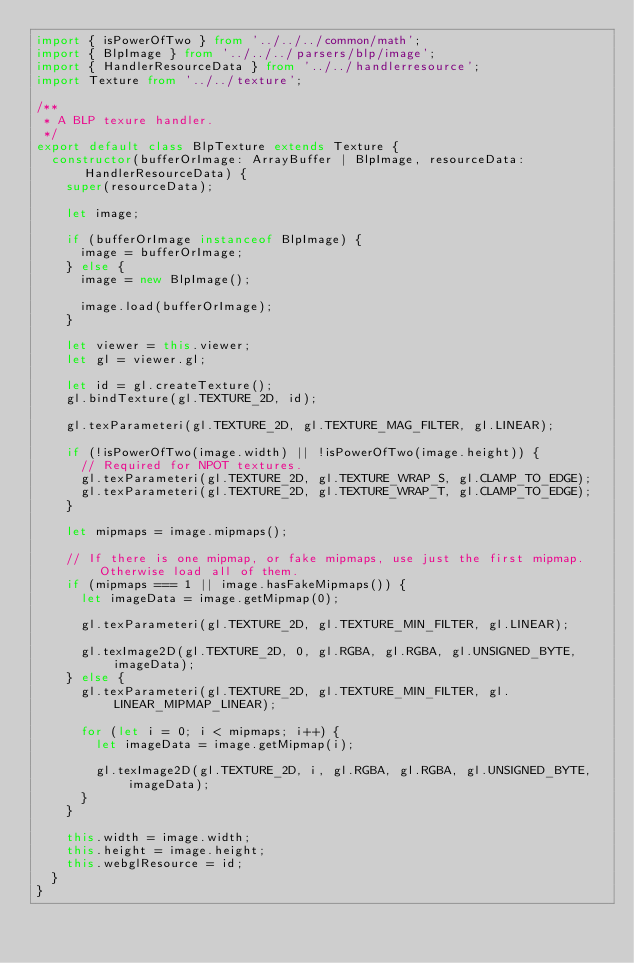<code> <loc_0><loc_0><loc_500><loc_500><_TypeScript_>import { isPowerOfTwo } from '../../../common/math';
import { BlpImage } from '../../../parsers/blp/image';
import { HandlerResourceData } from '../../handlerresource';
import Texture from '../../texture';

/**
 * A BLP texure handler.
 */
export default class BlpTexture extends Texture {
  constructor(bufferOrImage: ArrayBuffer | BlpImage, resourceData: HandlerResourceData) {
    super(resourceData);

    let image;

    if (bufferOrImage instanceof BlpImage) {
      image = bufferOrImage;
    } else {
      image = new BlpImage();

      image.load(bufferOrImage);
    }

    let viewer = this.viewer;
    let gl = viewer.gl;

    let id = gl.createTexture();
    gl.bindTexture(gl.TEXTURE_2D, id);

    gl.texParameteri(gl.TEXTURE_2D, gl.TEXTURE_MAG_FILTER, gl.LINEAR);

    if (!isPowerOfTwo(image.width) || !isPowerOfTwo(image.height)) {
      // Required for NPOT textures.
      gl.texParameteri(gl.TEXTURE_2D, gl.TEXTURE_WRAP_S, gl.CLAMP_TO_EDGE);
      gl.texParameteri(gl.TEXTURE_2D, gl.TEXTURE_WRAP_T, gl.CLAMP_TO_EDGE);
    }

    let mipmaps = image.mipmaps();

    // If there is one mipmap, or fake mipmaps, use just the first mipmap. Otherwise load all of them.
    if (mipmaps === 1 || image.hasFakeMipmaps()) {
      let imageData = image.getMipmap(0);

      gl.texParameteri(gl.TEXTURE_2D, gl.TEXTURE_MIN_FILTER, gl.LINEAR);

      gl.texImage2D(gl.TEXTURE_2D, 0, gl.RGBA, gl.RGBA, gl.UNSIGNED_BYTE, imageData);
    } else {
      gl.texParameteri(gl.TEXTURE_2D, gl.TEXTURE_MIN_FILTER, gl.LINEAR_MIPMAP_LINEAR);

      for (let i = 0; i < mipmaps; i++) {
        let imageData = image.getMipmap(i);

        gl.texImage2D(gl.TEXTURE_2D, i, gl.RGBA, gl.RGBA, gl.UNSIGNED_BYTE, imageData);
      }
    }

    this.width = image.width;
    this.height = image.height;
    this.webglResource = id;
  }
}
</code> 